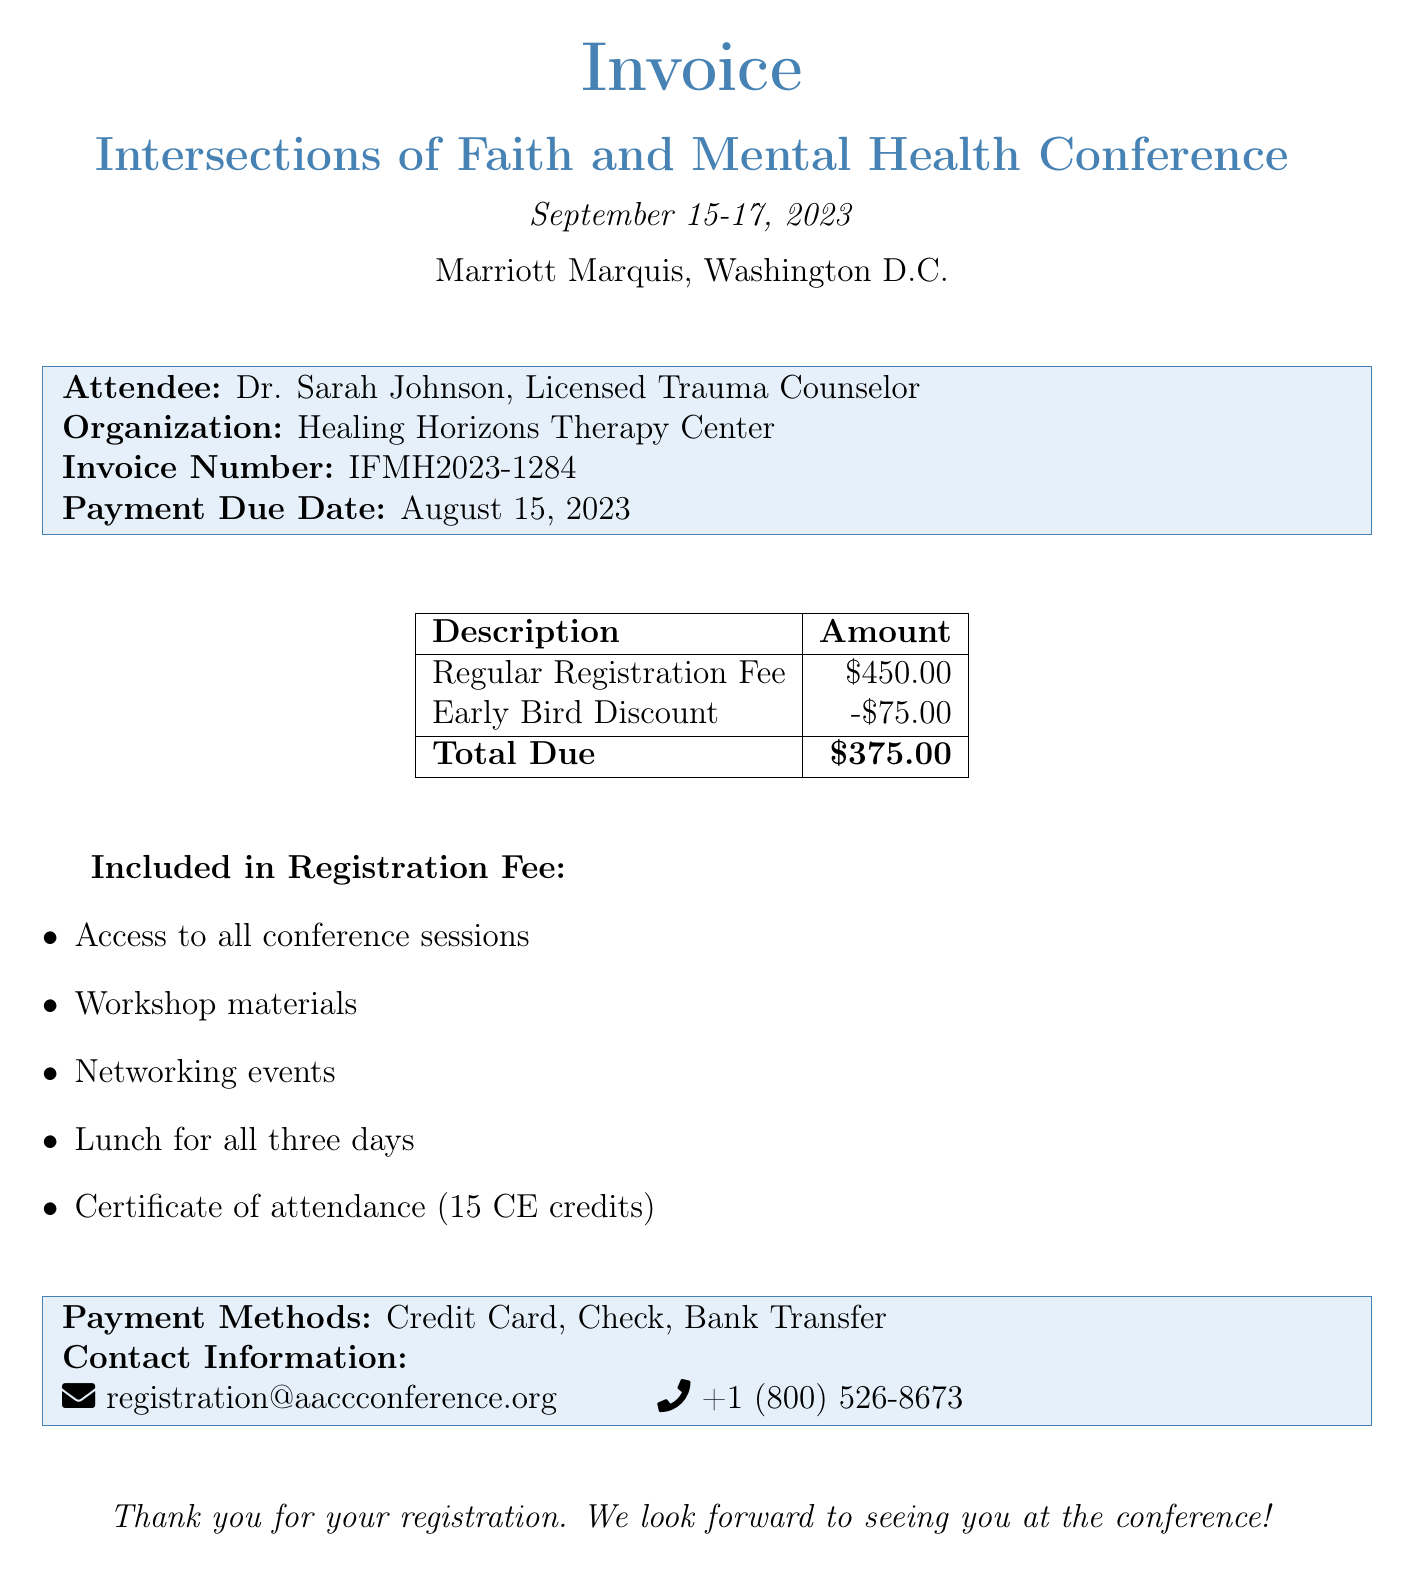What is the total amount due for the conference? The total amount due is stated at the bottom of the invoice. The invoice shows a total due of $375.00 after applying the early bird discount.
Answer: $375.00 What is the early bird discount amount? The early bird discount is specifically listed in the invoice, showing the amount deducted from the regular registration fee.
Answer: -$75.00 When is the payment due date? The payment due date is clearly stated in the invoice, which reads August 15, 2023.
Answer: August 15, 2023 What is the regular registration fee? The regular registration fee is mentioned in the detailed charges in the invoice.
Answer: $450.00 Who is the attendee named in the invoice? The attendee's name is listed as Dr. Sarah Johnson, who is a licensed trauma counselor.
Answer: Dr. Sarah Johnson What is included in the registration fee? The invoice includes a bulleted list specifying what is included in the registration fee, mentioning various items such as access to sessions and lunch.
Answer: Access to all conference sessions What is the invoice number? The invoice number is specified at the beginning of the attendee's details section.
Answer: IFMH2023-1284 Where is the conference taking place? The location of the conference is indicated in large text at the top of the invoice.
Answer: Marriott Marquis, Washington D.C What is the contact information for the registration? The invoice includes a section with contact information, listing an email and phone number for inquiries.
Answer: registration@aaccconference.org +1 (800) 526-8673 